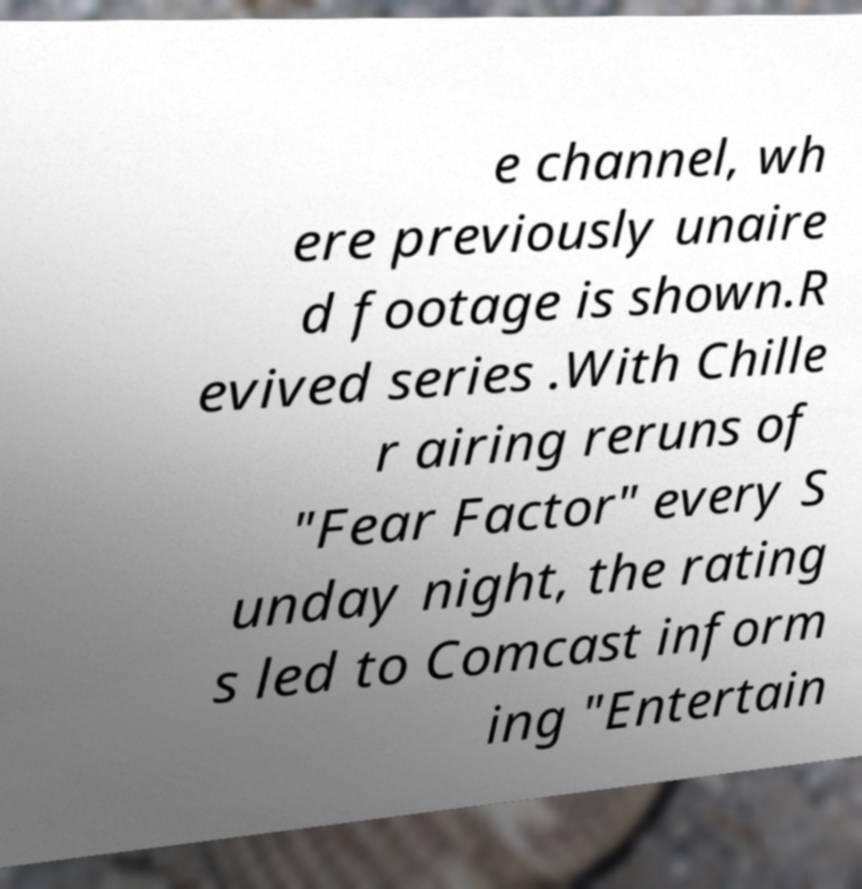Could you extract and type out the text from this image? e channel, wh ere previously unaire d footage is shown.R evived series .With Chille r airing reruns of "Fear Factor" every S unday night, the rating s led to Comcast inform ing "Entertain 